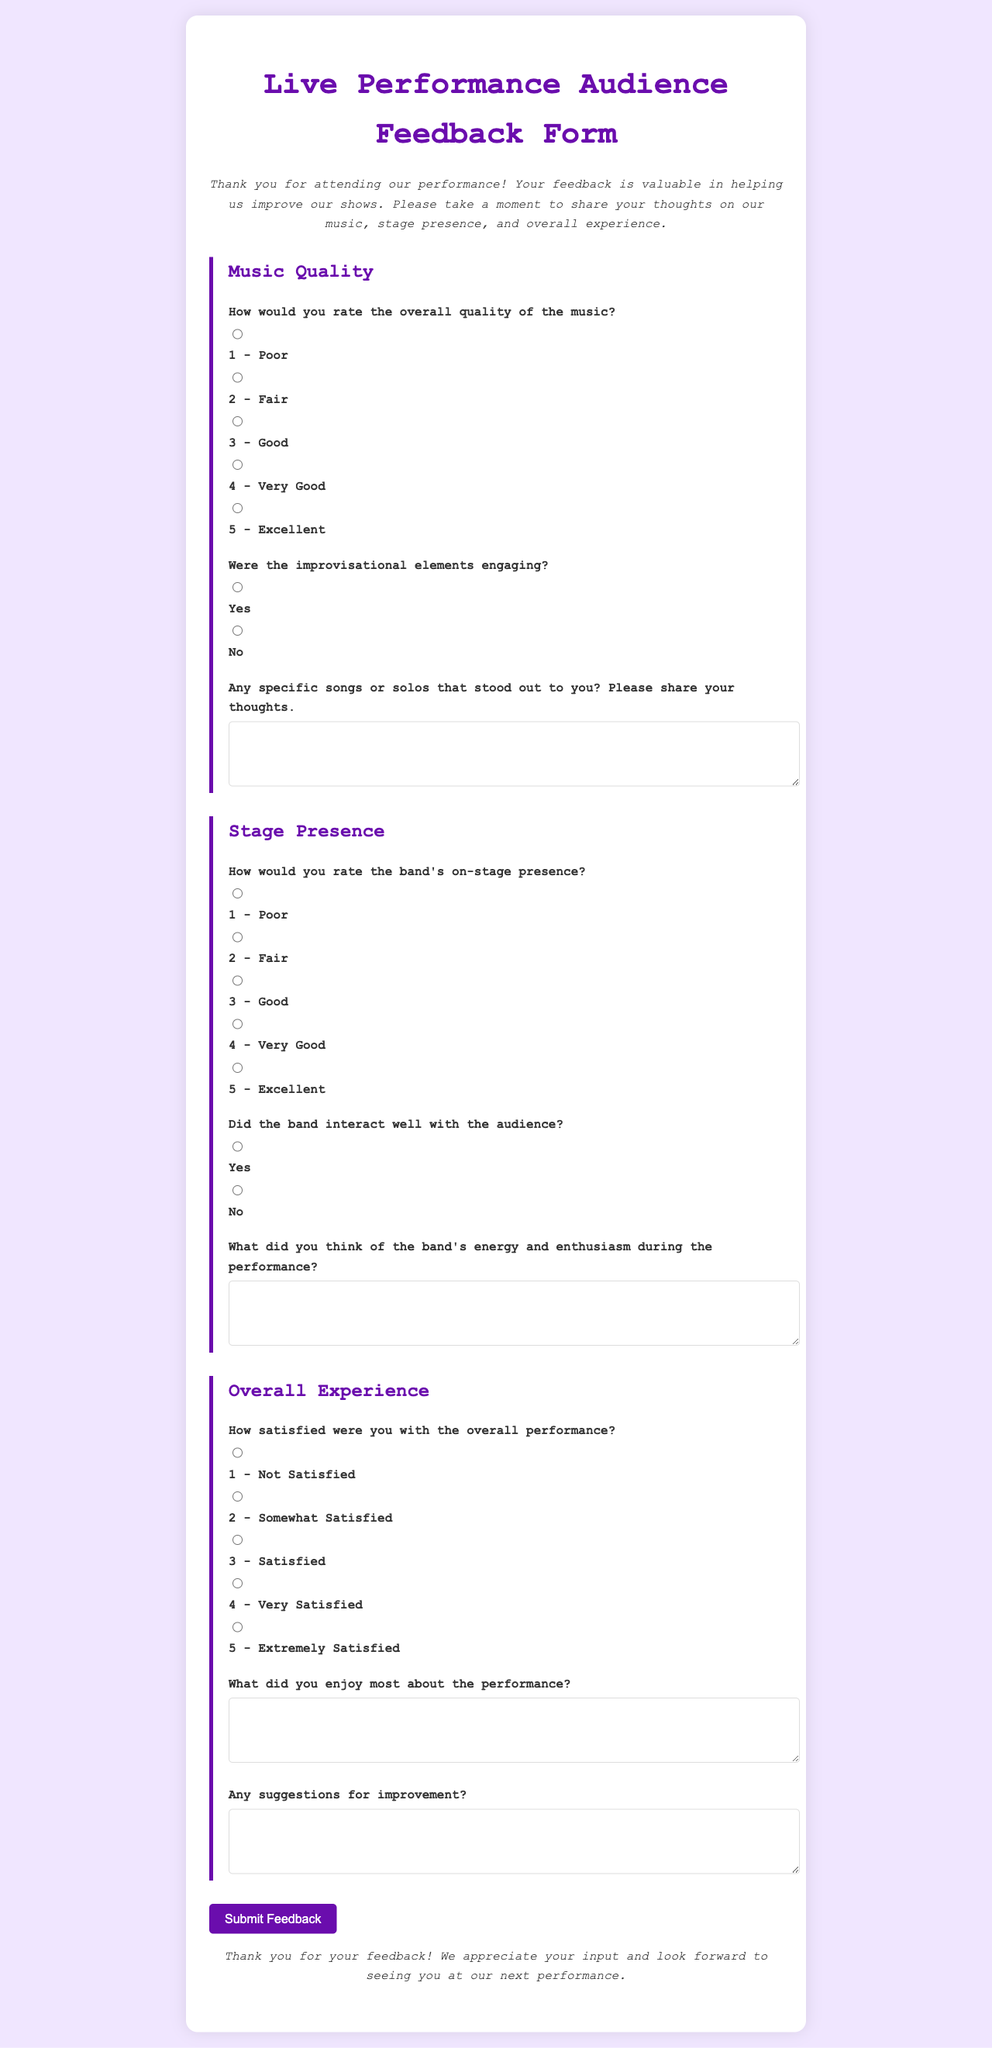What is the title of the form? The title of the form is presented prominently at the top of the document.
Answer: Live Performance Audience Feedback Form What color is used for the form's background? The background color of the document is specified in the style section of the code.
Answer: #f0e6ff How many sections are included in the form? The form contains three main sections, each addressing a different aspect of the performance.
Answer: 3 What is the maximum score for rating music quality? The highest rating available for music quality in the form is detailed among the options.
Answer: 5 Did the form ask if the band interacted well with the audience? The presence of such a question is confirmed in the stage presence section of the form.
Answer: Yes What feedback is requested regarding specific songs or solos? There is a question that invites feedback on particular performances that stood out during the show.
Answer: Any specific songs or solos that stood out to you? How does the form conclude? The closing statement is included to thank respondents for their participation.
Answer: Thank you for your feedback! What should respondents click to submit their feedback? The form includes a button labeled to enable submission of the provided feedback.
Answer: Submit Feedback 